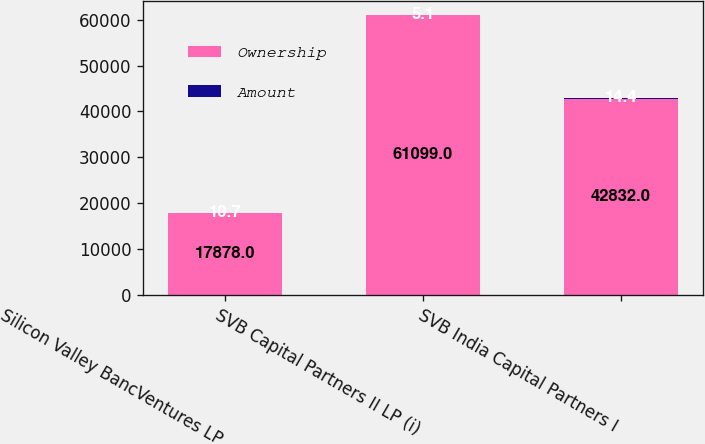Convert chart. <chart><loc_0><loc_0><loc_500><loc_500><stacked_bar_chart><ecel><fcel>Silicon Valley BancVentures LP<fcel>SVB Capital Partners II LP (i)<fcel>SVB India Capital Partners I<nl><fcel>Ownership<fcel>17878<fcel>61099<fcel>42832<nl><fcel>Amount<fcel>10.7<fcel>5.1<fcel>14.4<nl></chart> 